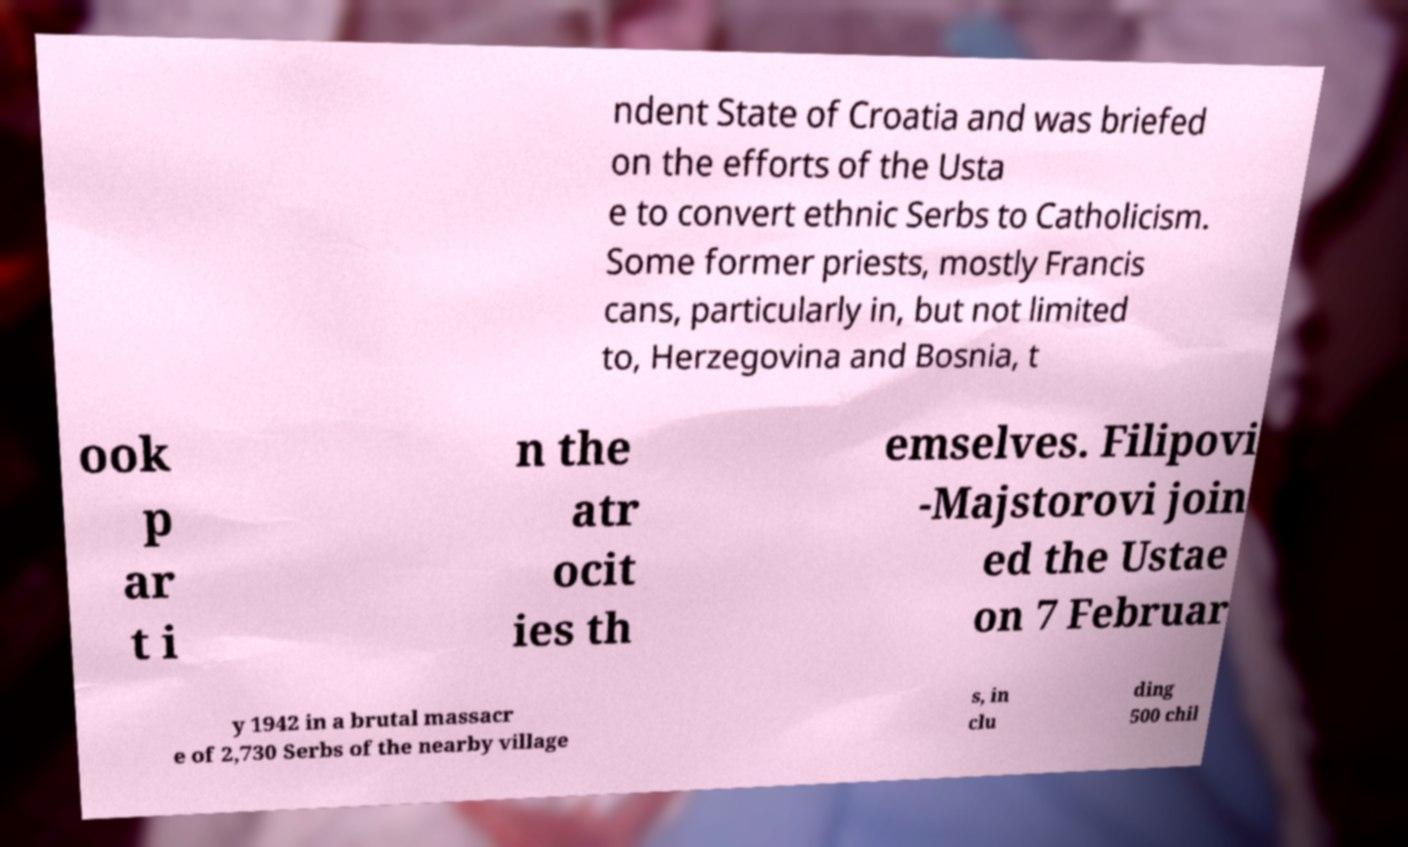I need the written content from this picture converted into text. Can you do that? ndent State of Croatia and was briefed on the efforts of the Usta e to convert ethnic Serbs to Catholicism. Some former priests, mostly Francis cans, particularly in, but not limited to, Herzegovina and Bosnia, t ook p ar t i n the atr ocit ies th emselves. Filipovi -Majstorovi join ed the Ustae on 7 Februar y 1942 in a brutal massacr e of 2,730 Serbs of the nearby village s, in clu ding 500 chil 